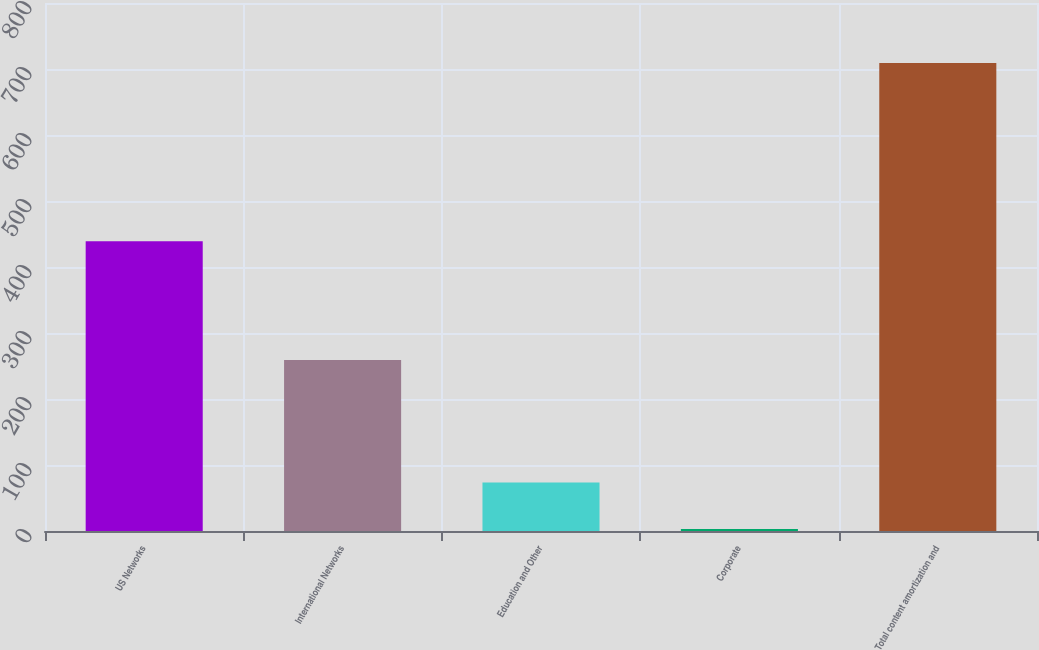Convert chart to OTSL. <chart><loc_0><loc_0><loc_500><loc_500><bar_chart><fcel>US Networks<fcel>International Networks<fcel>Education and Other<fcel>Corporate<fcel>Total content amortization and<nl><fcel>439<fcel>259<fcel>73.6<fcel>3<fcel>709<nl></chart> 